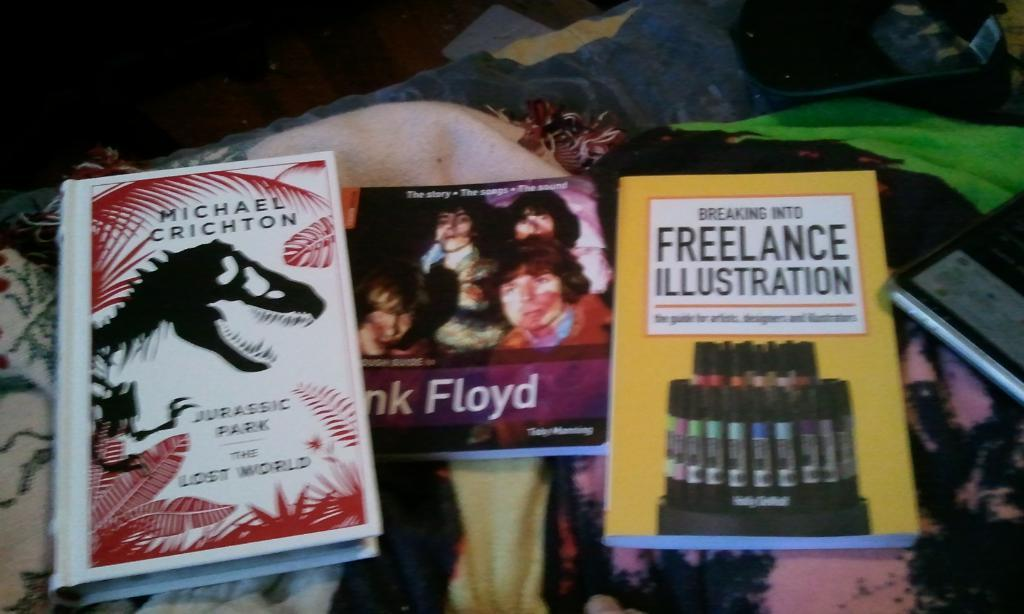<image>
Present a compact description of the photo's key features. A copy of Michael Crichton's Jurassic Park The Lost World sits near a Pink Floyd book. 